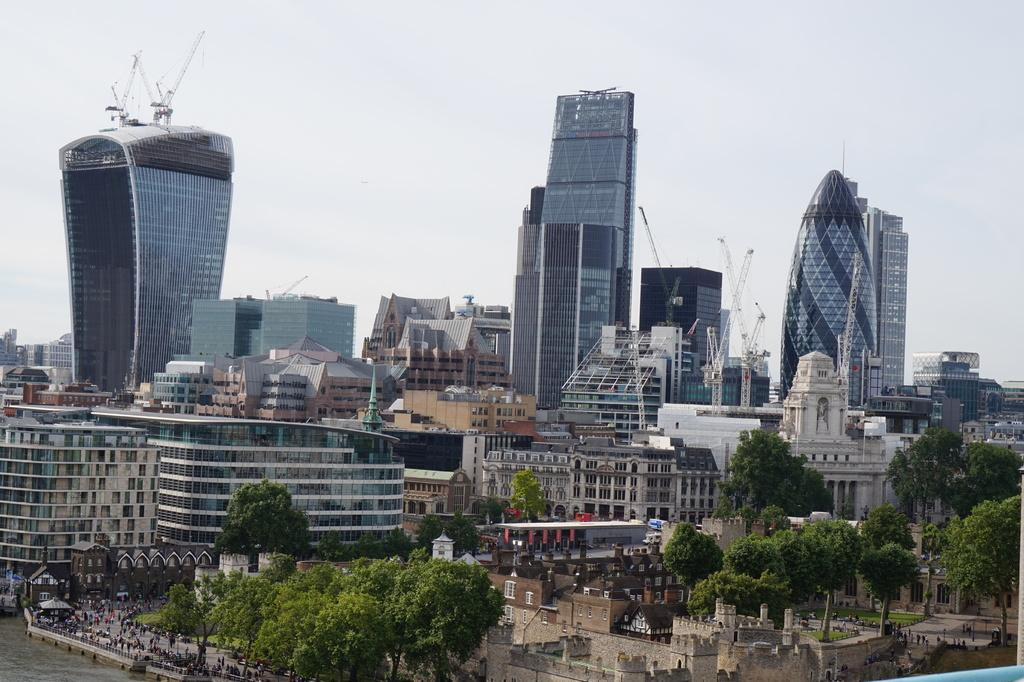What type of structures can be seen in the image? There are buildings in the image. What natural elements are present in the image? There are trees, water, and grass visible in the image. Are there any living beings in the image? Yes, there are people in the image. What material are the windows of the buildings made of? The windows of the buildings are made of glass. What can be seen in the background of the image? The sky is visible in the background of the image. Can you see a cap on the head of the crow in the image? There is no crow present in the image, so it is not possible to see a cap on its head. 